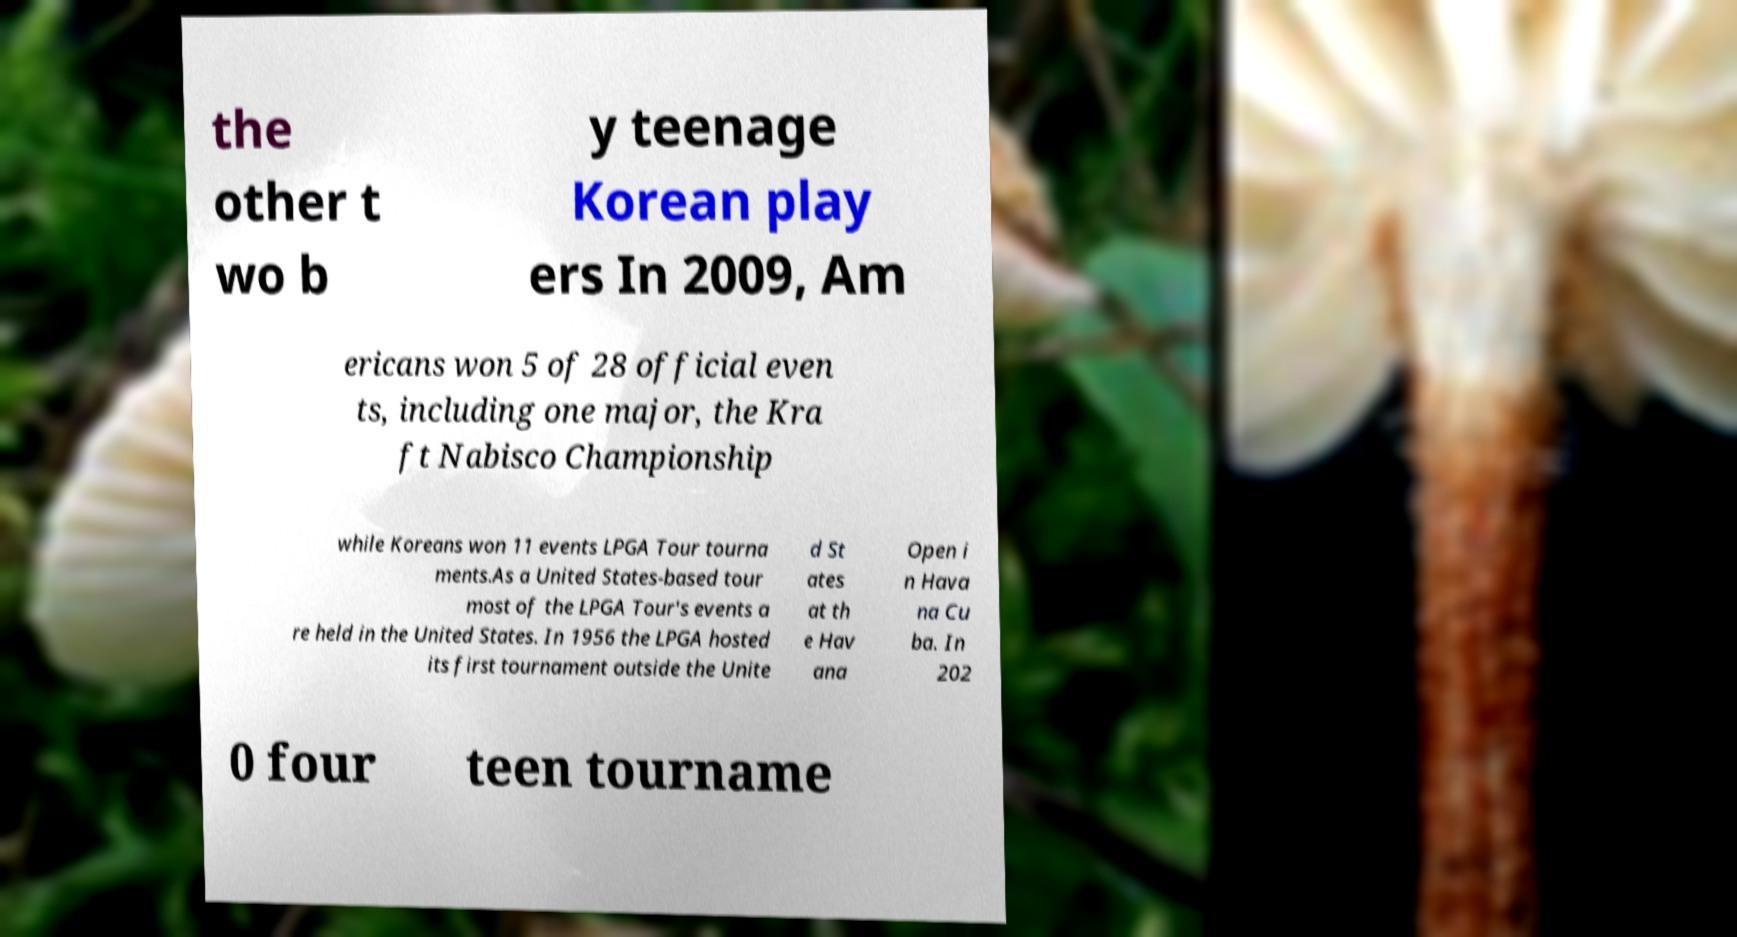Could you assist in decoding the text presented in this image and type it out clearly? the other t wo b y teenage Korean play ers In 2009, Am ericans won 5 of 28 official even ts, including one major, the Kra ft Nabisco Championship while Koreans won 11 events LPGA Tour tourna ments.As a United States-based tour most of the LPGA Tour's events a re held in the United States. In 1956 the LPGA hosted its first tournament outside the Unite d St ates at th e Hav ana Open i n Hava na Cu ba. In 202 0 four teen tourname 